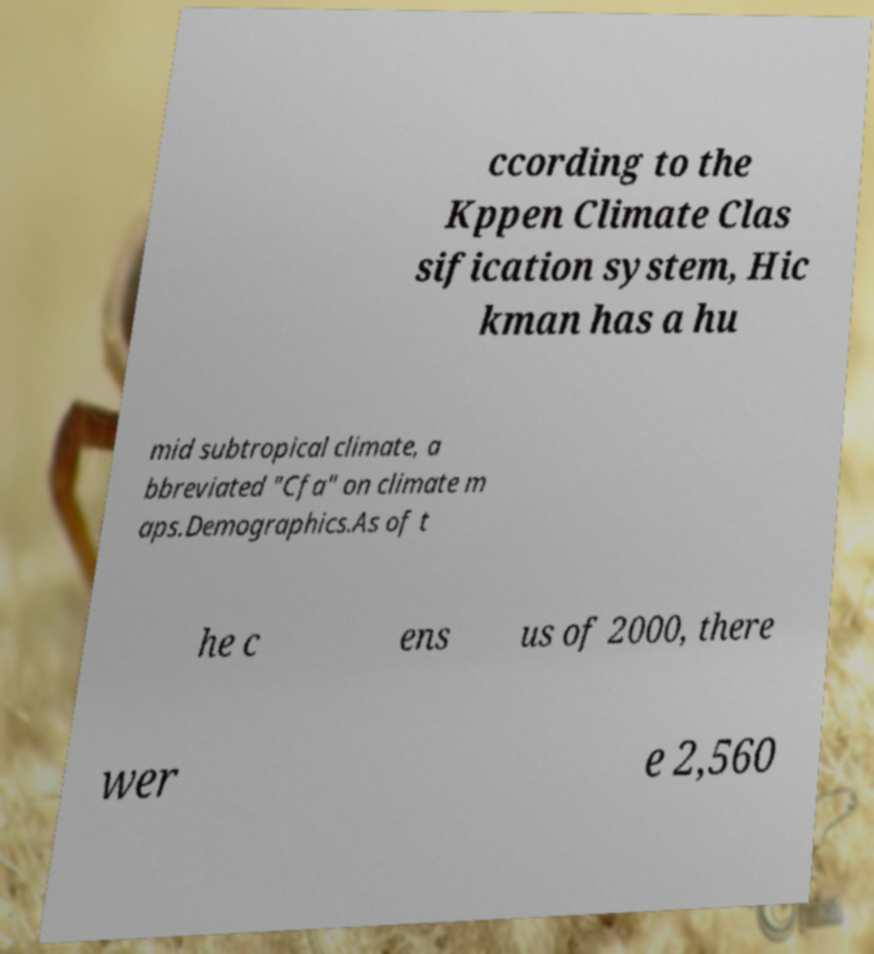I need the written content from this picture converted into text. Can you do that? ccording to the Kppen Climate Clas sification system, Hic kman has a hu mid subtropical climate, a bbreviated "Cfa" on climate m aps.Demographics.As of t he c ens us of 2000, there wer e 2,560 